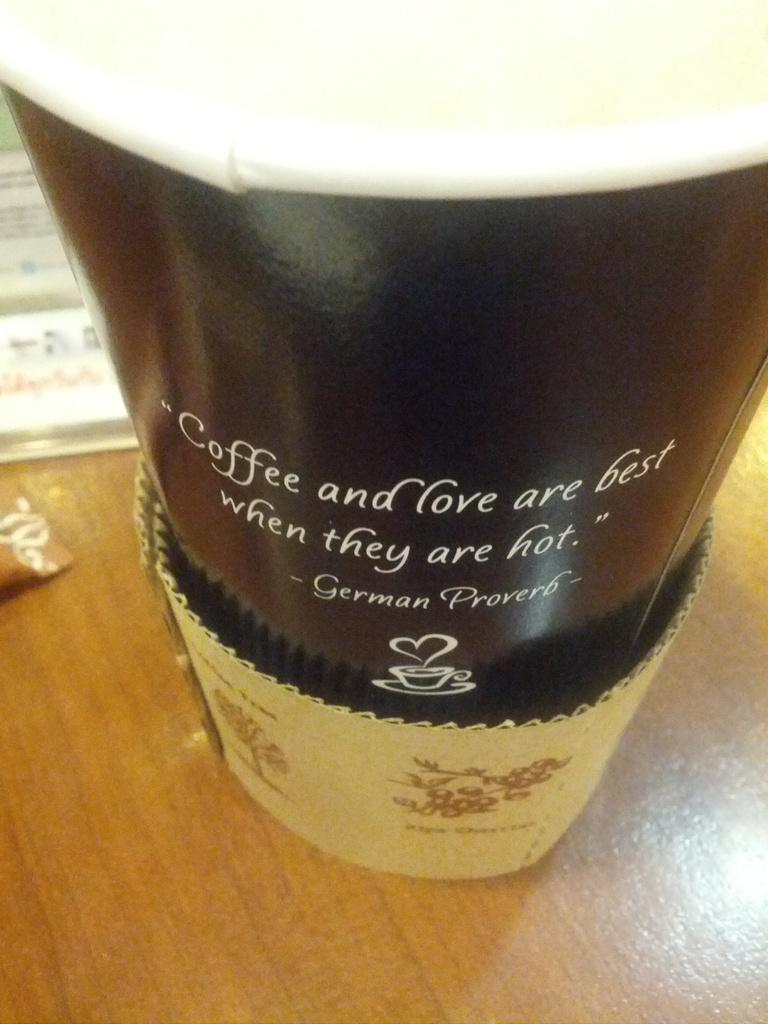Could you give a brief overview of what you see in this image? In this picture we can see a glass on the wooden surface and some objects. 